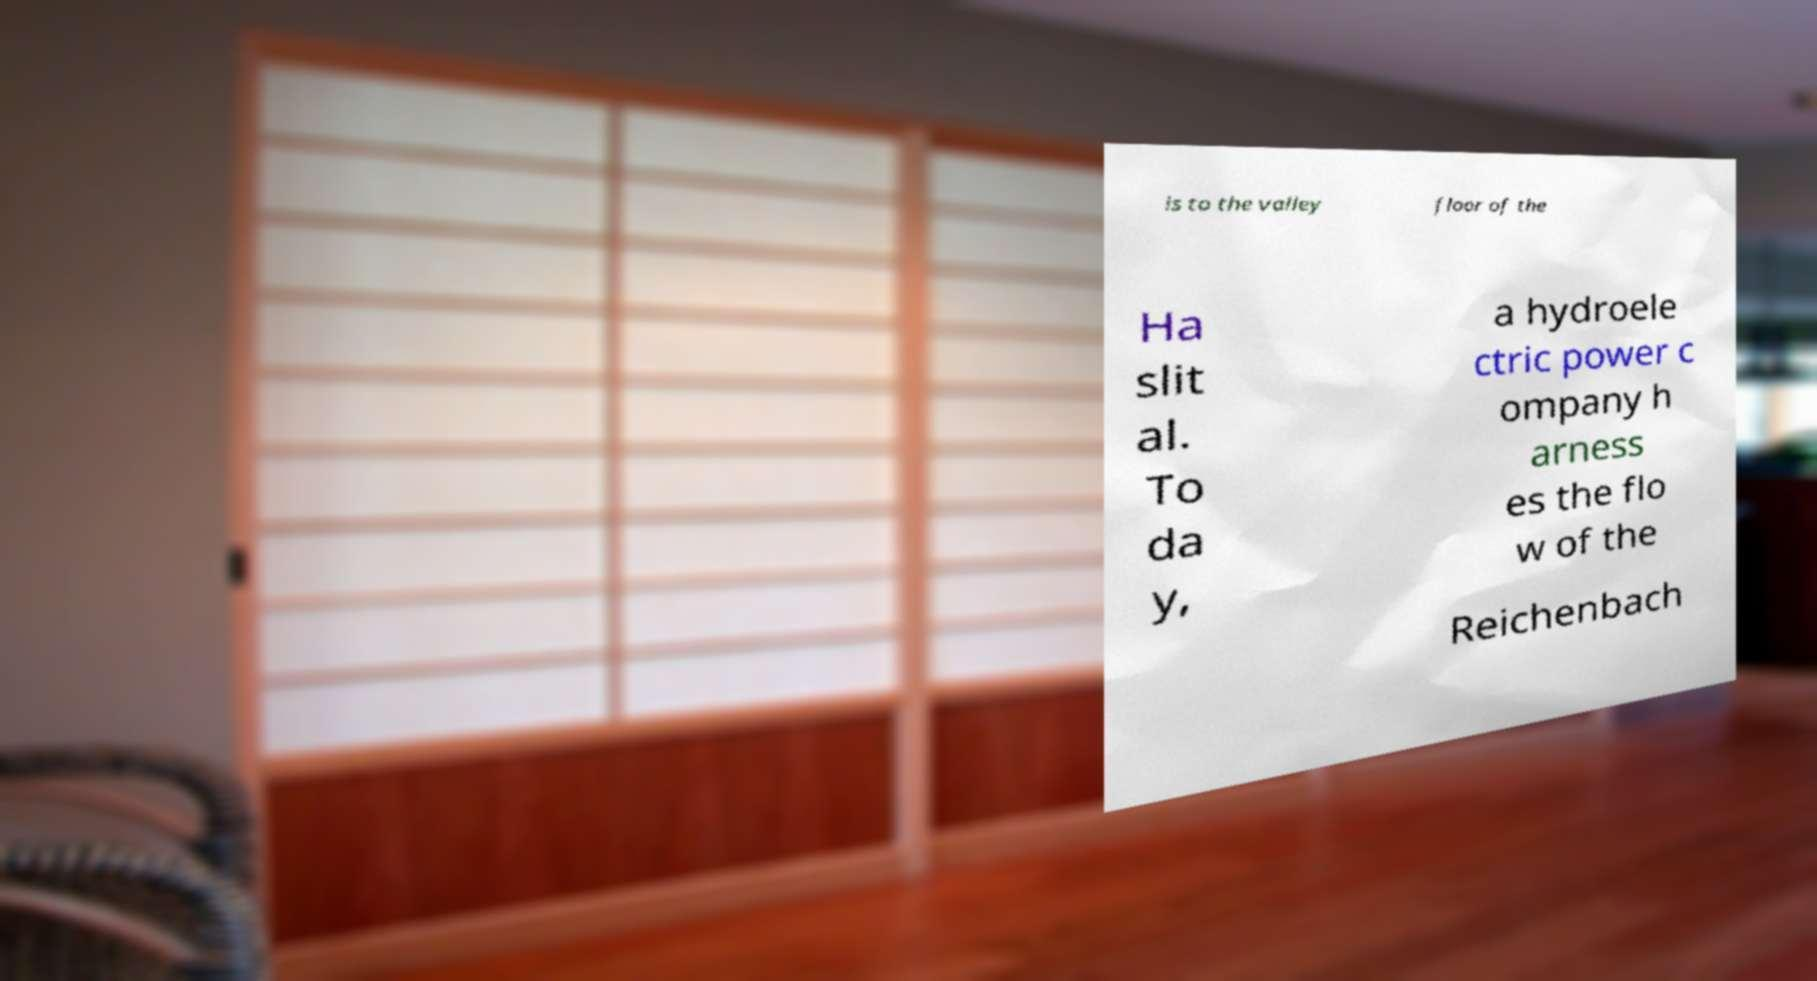I need the written content from this picture converted into text. Can you do that? ls to the valley floor of the Ha slit al. To da y, a hydroele ctric power c ompany h arness es the flo w of the Reichenbach 